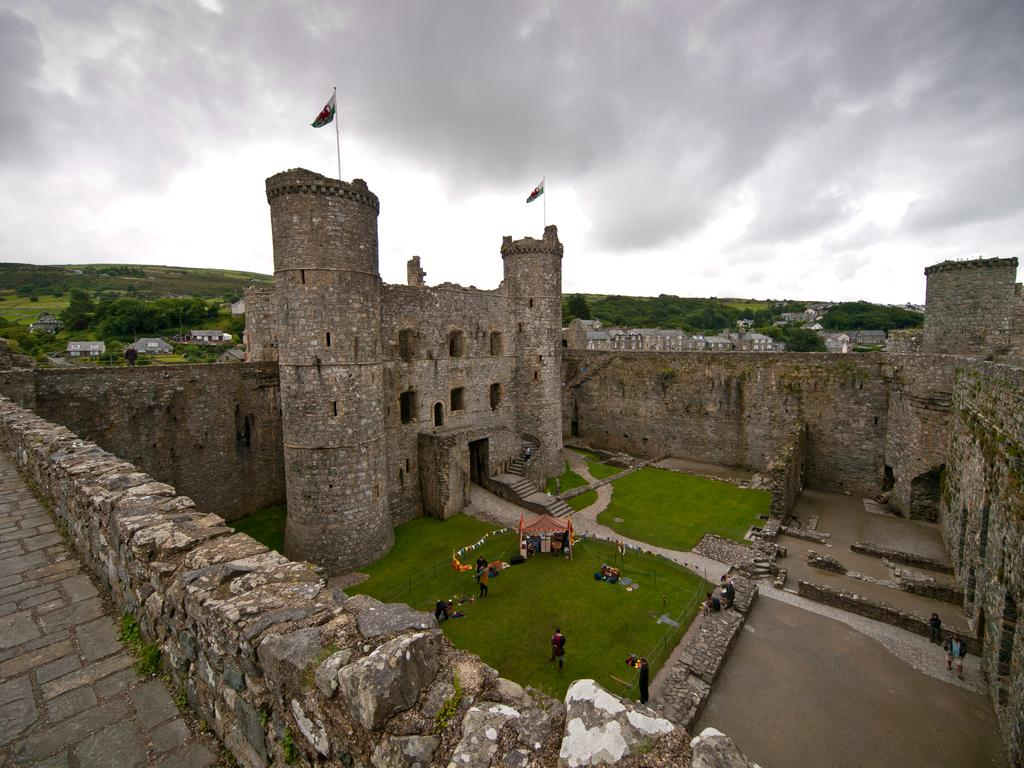What is the main structure in the image? There is a fort in the image. Can you describe the people in the image? There is a group of people standing in the image. What type of temporary structure can be seen in the image? There is a stall in the image. What are the flags attached to in the image? There are flags with poles in the image. What can be seen in the distance in the image? There are buildings, trees, hills, and the sky visible in the background of the image. What type of rhythm can be heard coming from the fort in the image? There is no indication of any sound or rhythm in the image, as it is a still photograph. 